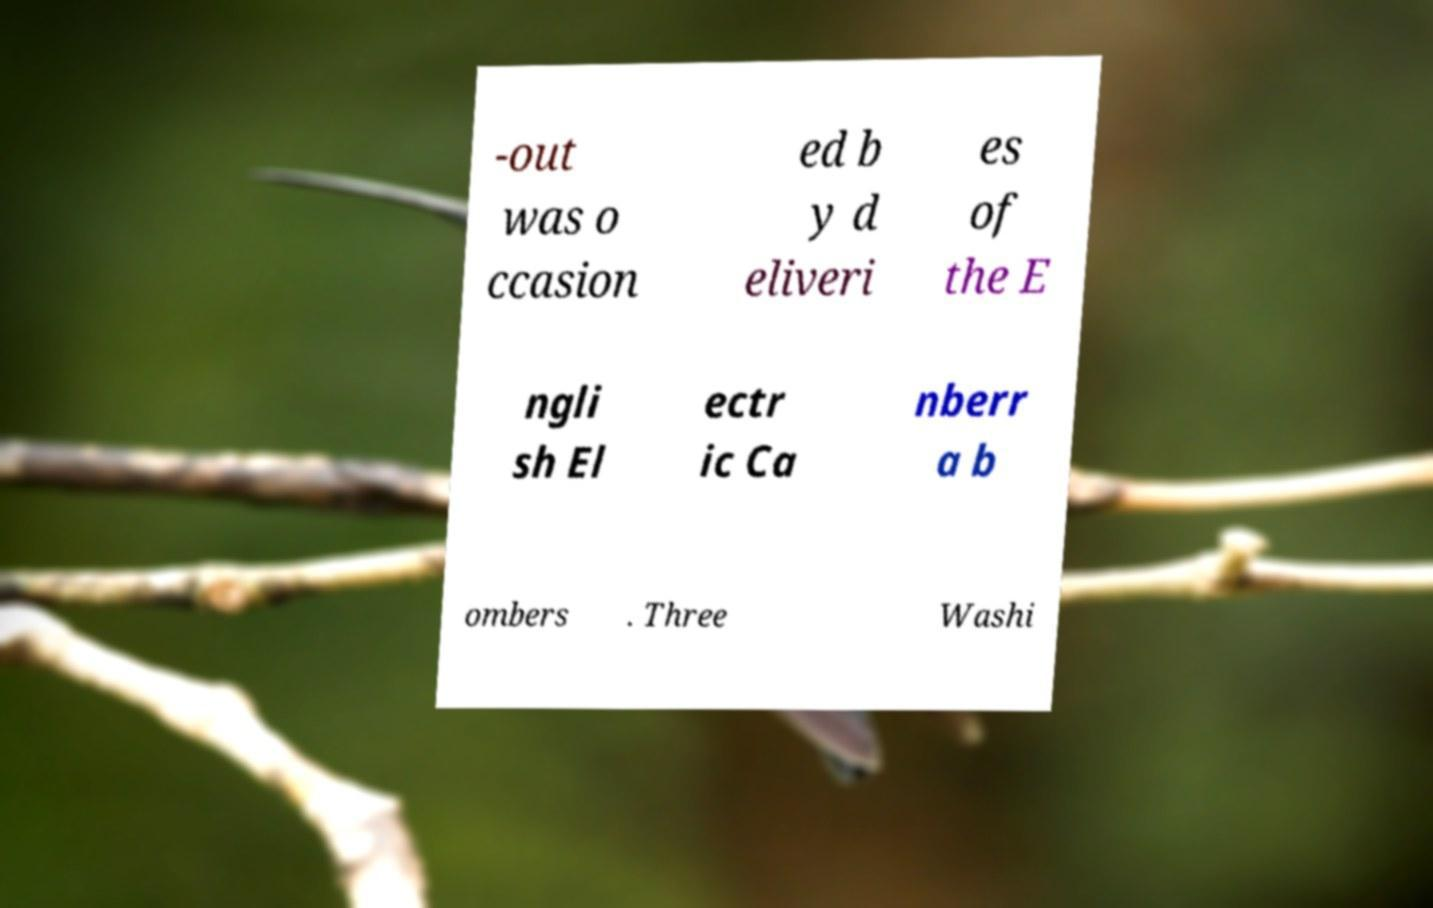Could you extract and type out the text from this image? -out was o ccasion ed b y d eliveri es of the E ngli sh El ectr ic Ca nberr a b ombers . Three Washi 